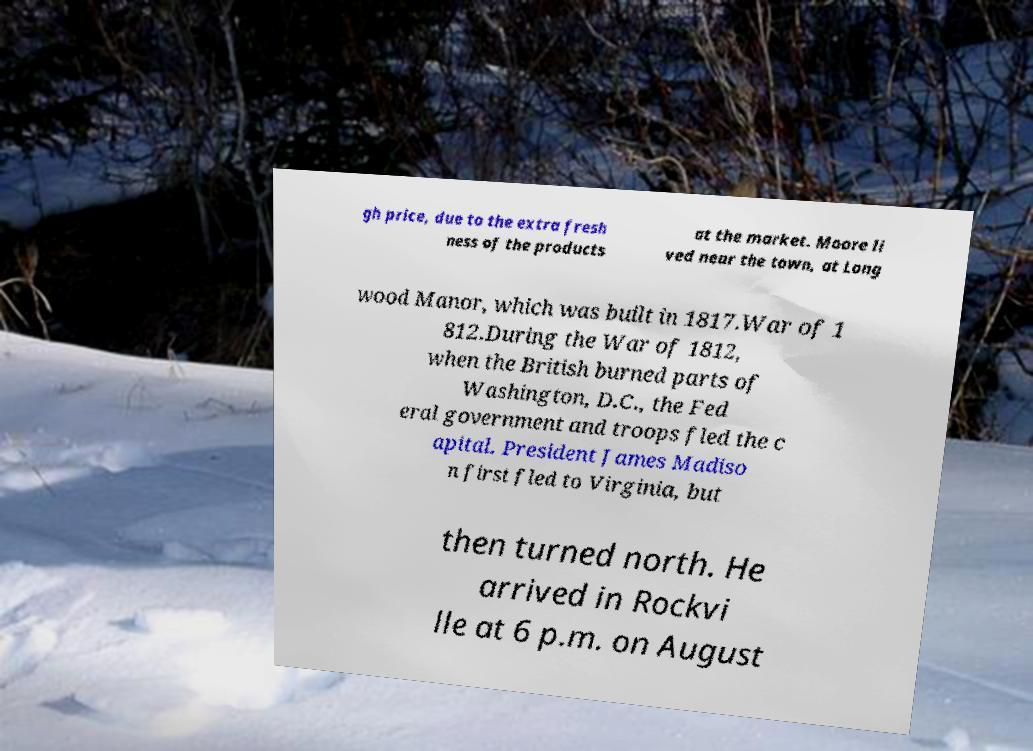What messages or text are displayed in this image? I need them in a readable, typed format. gh price, due to the extra fresh ness of the products at the market. Moore li ved near the town, at Long wood Manor, which was built in 1817.War of 1 812.During the War of 1812, when the British burned parts of Washington, D.C., the Fed eral government and troops fled the c apital. President James Madiso n first fled to Virginia, but then turned north. He arrived in Rockvi lle at 6 p.m. on August 